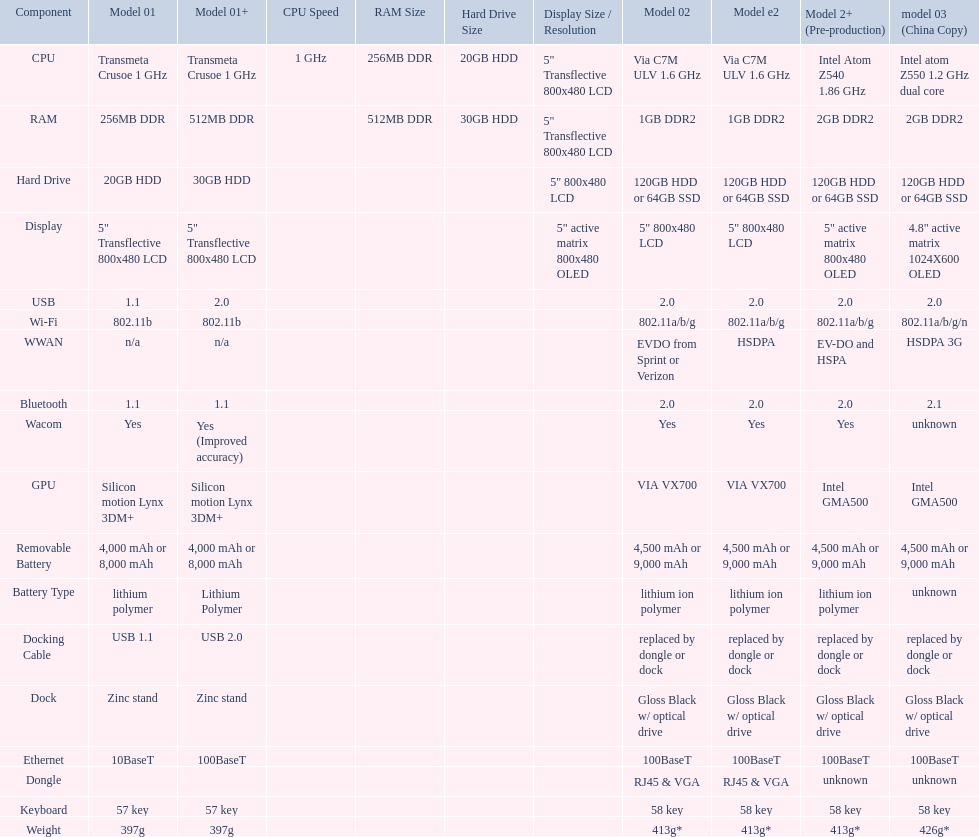What is the next highest hard drive available after the 30gb model? 64GB SSD. 